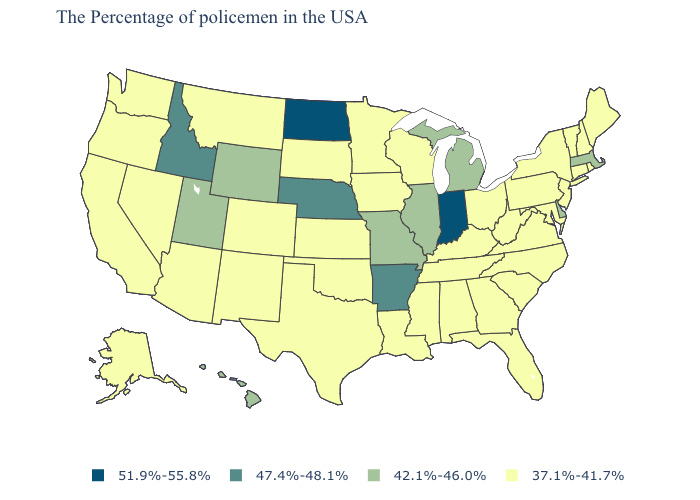What is the lowest value in the USA?
Write a very short answer. 37.1%-41.7%. Name the states that have a value in the range 37.1%-41.7%?
Be succinct. Maine, Rhode Island, New Hampshire, Vermont, Connecticut, New York, New Jersey, Maryland, Pennsylvania, Virginia, North Carolina, South Carolina, West Virginia, Ohio, Florida, Georgia, Kentucky, Alabama, Tennessee, Wisconsin, Mississippi, Louisiana, Minnesota, Iowa, Kansas, Oklahoma, Texas, South Dakota, Colorado, New Mexico, Montana, Arizona, Nevada, California, Washington, Oregon, Alaska. Does Indiana have the highest value in the USA?
Be succinct. Yes. What is the highest value in the MidWest ?
Give a very brief answer. 51.9%-55.8%. Does New Hampshire have the lowest value in the USA?
Be succinct. Yes. What is the value of South Carolina?
Concise answer only. 37.1%-41.7%. Does Alabama have the highest value in the USA?
Give a very brief answer. No. What is the value of Texas?
Be succinct. 37.1%-41.7%. What is the highest value in states that border New York?
Give a very brief answer. 42.1%-46.0%. Does New Hampshire have the lowest value in the Northeast?
Concise answer only. Yes. What is the value of Massachusetts?
Give a very brief answer. 42.1%-46.0%. Which states hav the highest value in the MidWest?
Quick response, please. Indiana, North Dakota. Does South Dakota have the same value as South Carolina?
Concise answer only. Yes. What is the highest value in the USA?
Quick response, please. 51.9%-55.8%. Does Idaho have a higher value than New Mexico?
Write a very short answer. Yes. 